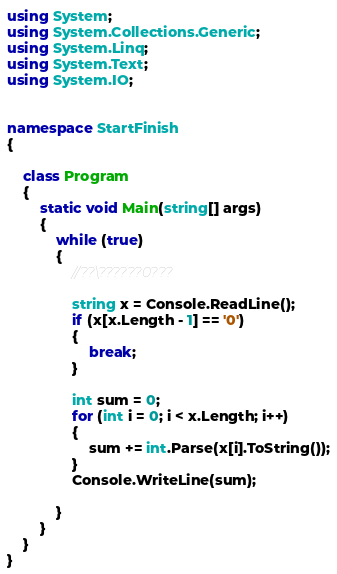Convert code to text. <code><loc_0><loc_0><loc_500><loc_500><_C#_>
using System;
using System.Collections.Generic;
using System.Linq;
using System.Text;
using System.IO;


namespace StartFinish
{

    class Program
    {
        static void Main(string[] args)
        {
            while (true)
            {
                //??\??????0???

                string x = Console.ReadLine();
                if (x[x.Length - 1] == '0')
                {
                    break;
                }

                int sum = 0;
                for (int i = 0; i < x.Length; i++)
                {
                    sum += int.Parse(x[i].ToString());
                }
                Console.WriteLine(sum);

            }
        }
    }
}</code> 